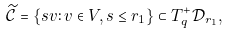<formula> <loc_0><loc_0><loc_500><loc_500>\widetilde { \mathcal { C } } = \{ s v \colon v \in V , s \leq r _ { 1 } \} \subset T _ { q } ^ { + } { \mathcal { D } } _ { r _ { 1 } } ,</formula> 